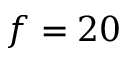Convert formula to latex. <formula><loc_0><loc_0><loc_500><loc_500>f = 2 0</formula> 